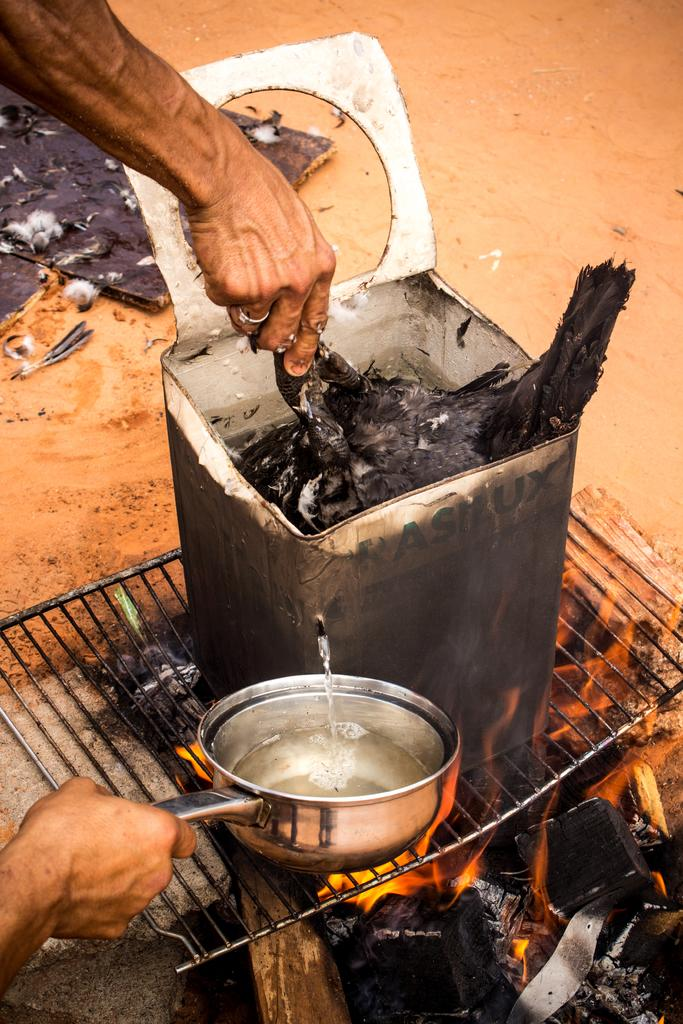What object is present in the image that can hold or store items? There is a container in the image. What material is visible in the image that is commonly used for construction or furniture? Wood is present in the image. What substance is visible in the image that is typically used for cooking or heating? Charcoal is visible in the image. What natural phenomenon is present in the image that produces light and heat? Fire is present in the image. What type of terrain is visible in the image that is typically found near bodies of water? Sand is visible in the image. What type of jewelry is present in the image that is often worn on a finger? There is a finger ring in the image. What type of rock is present in the image that is often used for construction or decoration? A stone is present in the image. What type of cooking equipment is visible in the image that is used to hold food over a heat source? A grill net is visible in the image. What part of the human body is present in the image that is used for grasping or manipulating objects? Human hands are present in the image. How many babies are present in the image? There are no babies present in the image. What type of adhesive is visible in the image that is used to join objects together? There is no glue present in the image. What type of event is depicted in the image that is associated with death or mourning? There is no event associated with death or mourning depicted in the image. 